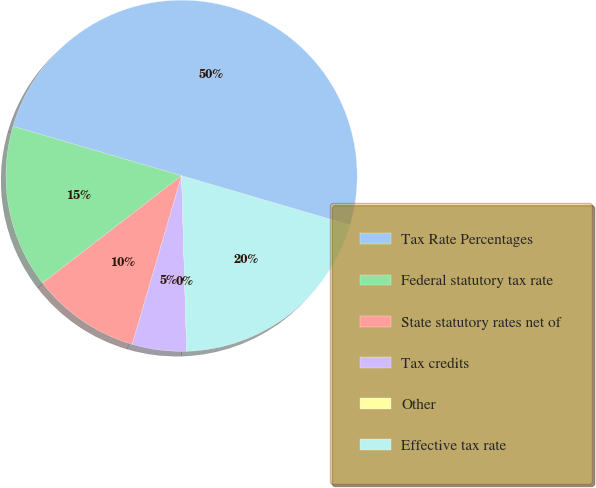Convert chart. <chart><loc_0><loc_0><loc_500><loc_500><pie_chart><fcel>Tax Rate Percentages<fcel>Federal statutory tax rate<fcel>State statutory rates net of<fcel>Tax credits<fcel>Other<fcel>Effective tax rate<nl><fcel>50.0%<fcel>15.0%<fcel>10.0%<fcel>5.0%<fcel>0.0%<fcel>20.0%<nl></chart> 